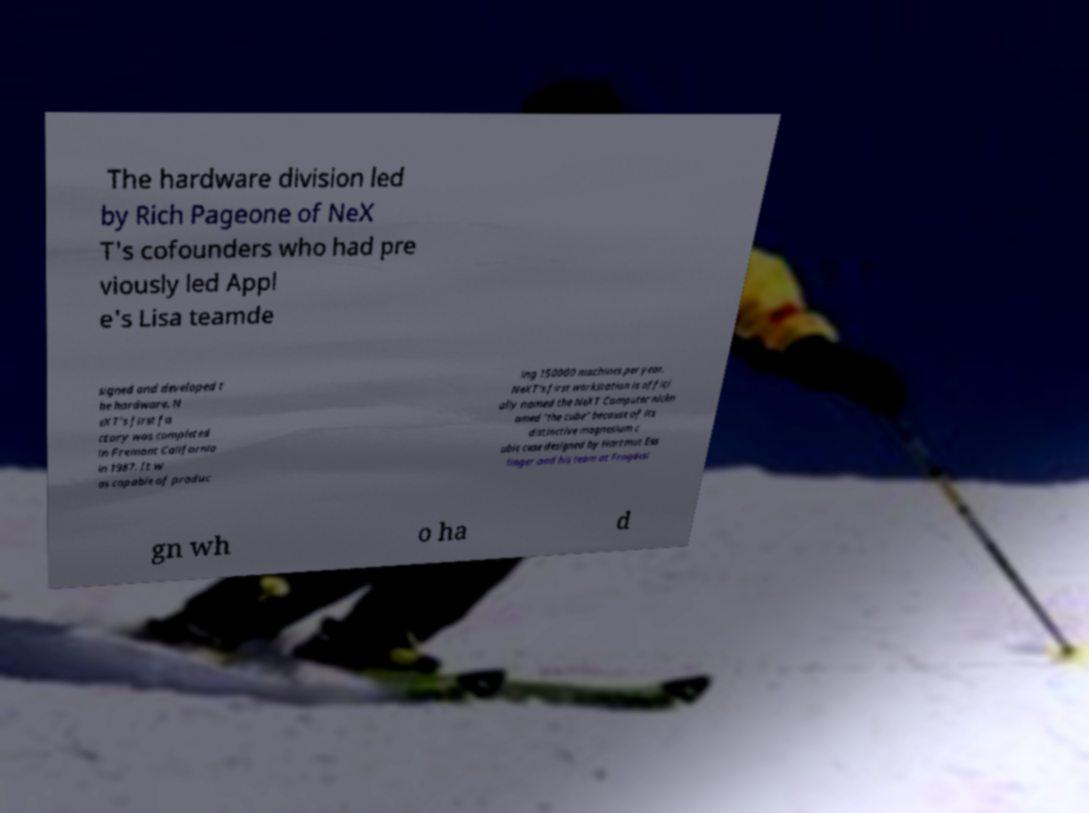There's text embedded in this image that I need extracted. Can you transcribe it verbatim? The hardware division led by Rich Pageone of NeX T's cofounders who had pre viously led Appl e's Lisa teamde signed and developed t he hardware. N eXT's first fa ctory was completed in Fremont California in 1987. It w as capable of produc ing 150000 machines per year. NeXT's first workstation is offici ally named the NeXT Computer nickn amed "the cube" because of its distinctive magnesium c ubic case designed by Hartmut Ess linger and his team at Frogdesi gn wh o ha d 